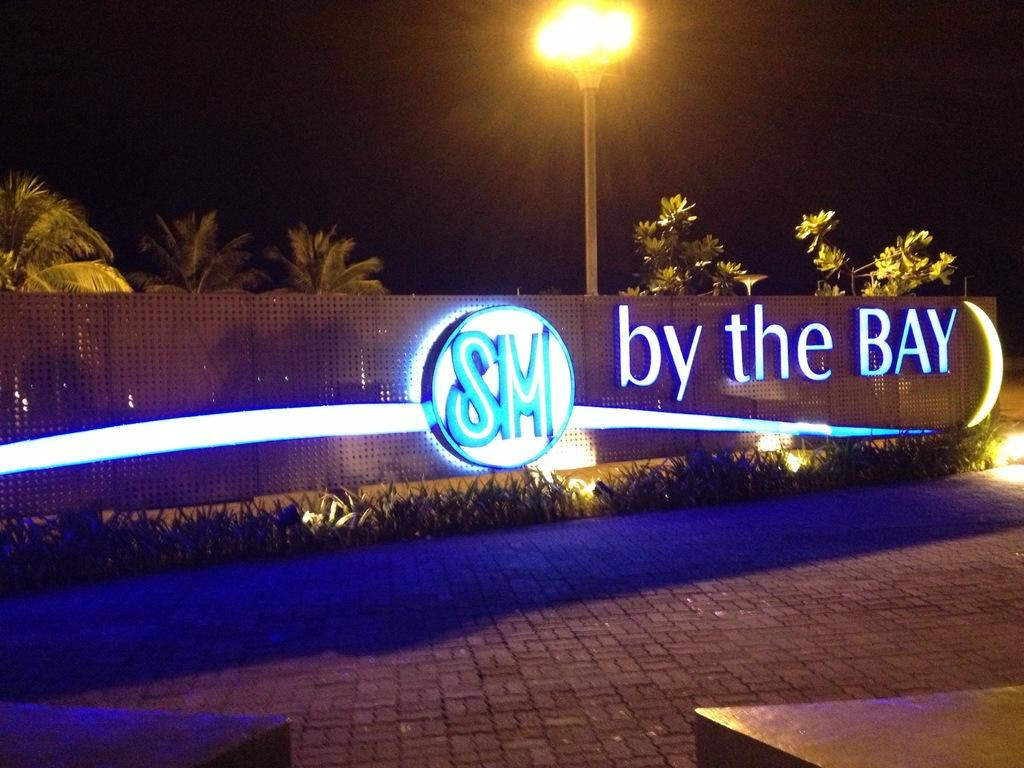What is written on the board in the image? The board in the image has the name "by the bay" written on it. What is located in front of the board? There are plants in front of the board. What is located behind the board? There are trees behind the board. What type of structure is visible in the image? There is a light pole visible in the image. What year is depicted on the board in the image? The board does not display a year; it only has the name "by the bay" written on it. What type of pen is used to write the name on the board? There is no pen visible in the image, and the method of writing the name on the board is not mentioned. 